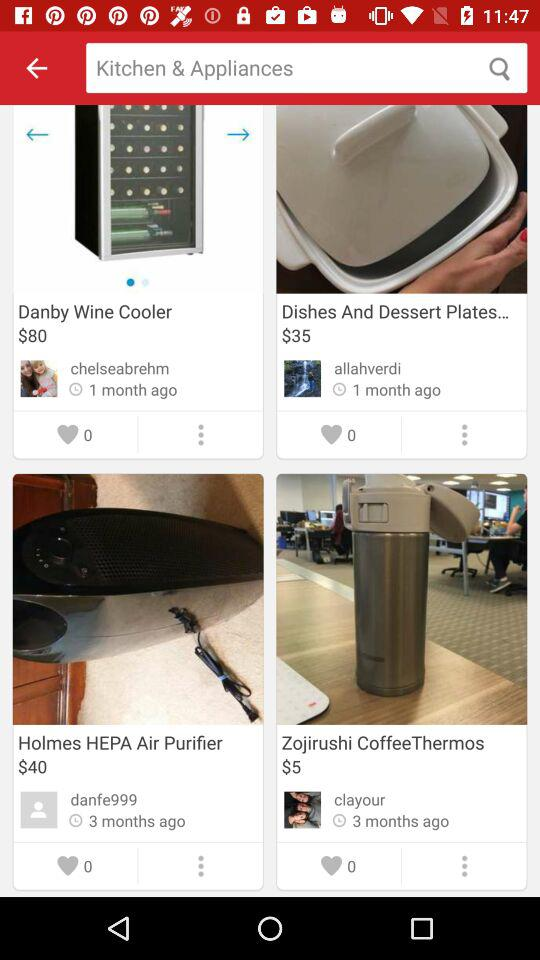How many more dollars is the Danby Wine Cooler than the Holmes HEPA Air Purifier?
Answer the question using a single word or phrase. 40 